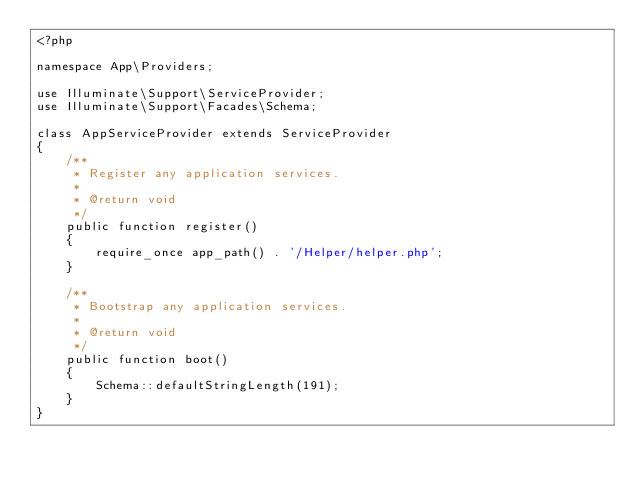<code> <loc_0><loc_0><loc_500><loc_500><_PHP_><?php

namespace App\Providers;

use Illuminate\Support\ServiceProvider;
use Illuminate\Support\Facades\Schema;

class AppServiceProvider extends ServiceProvider
{
    /**
     * Register any application services.
     *
     * @return void
     */
    public function register()
    {
        require_once app_path() . '/Helper/helper.php';
    }

    /**
     * Bootstrap any application services.
     *
     * @return void
     */
    public function boot()
    {
        Schema::defaultStringLength(191);
    }
}
</code> 